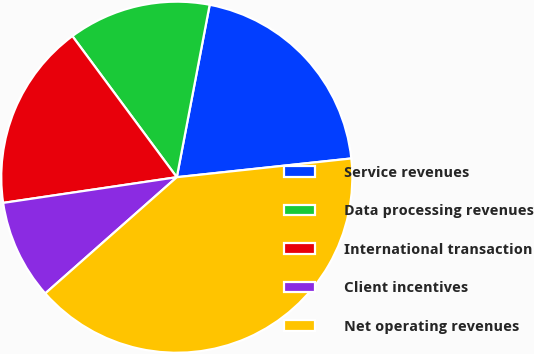Convert chart. <chart><loc_0><loc_0><loc_500><loc_500><pie_chart><fcel>Service revenues<fcel>Data processing revenues<fcel>International transaction<fcel>Client incentives<fcel>Net operating revenues<nl><fcel>20.3%<fcel>13.14%<fcel>17.2%<fcel>9.18%<fcel>40.19%<nl></chart> 